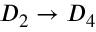<formula> <loc_0><loc_0><loc_500><loc_500>D _ { 2 } \to D _ { 4 }</formula> 